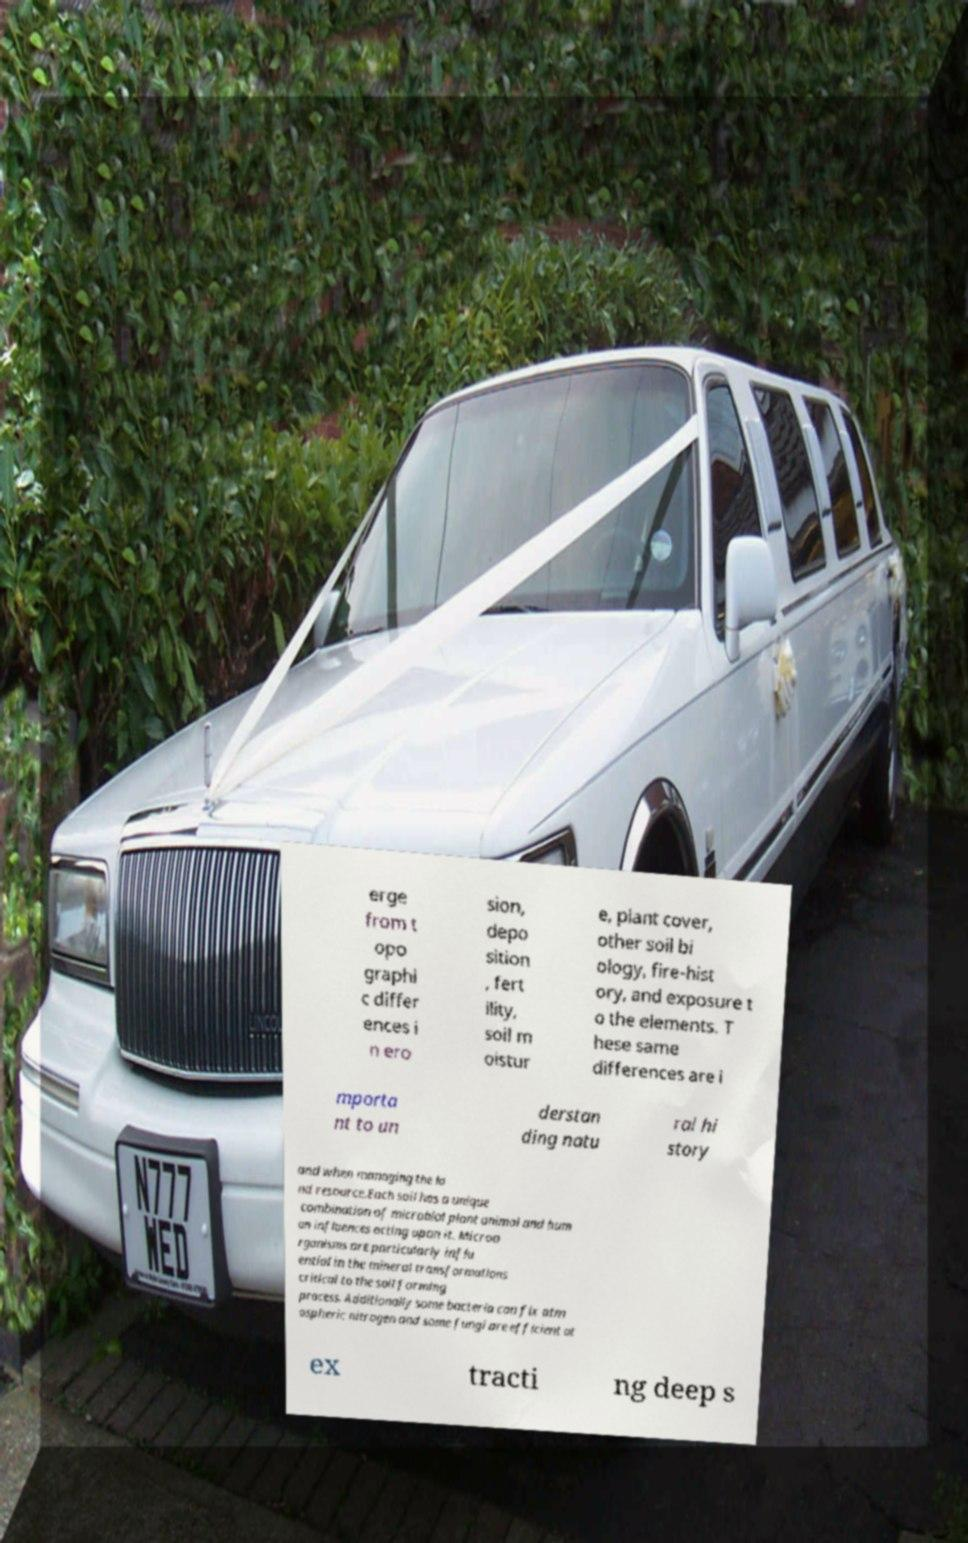Can you accurately transcribe the text from the provided image for me? erge from t opo graphi c differ ences i n ero sion, depo sition , fert ility, soil m oistur e, plant cover, other soil bi ology, fire-hist ory, and exposure t o the elements. T hese same differences are i mporta nt to un derstan ding natu ral hi story and when managing the la nd resource.Each soil has a unique combination of microbial plant animal and hum an influences acting upon it. Microo rganisms are particularly influ ential in the mineral transformations critical to the soil forming process. Additionally some bacteria can fix atm ospheric nitrogen and some fungi are efficient at ex tracti ng deep s 